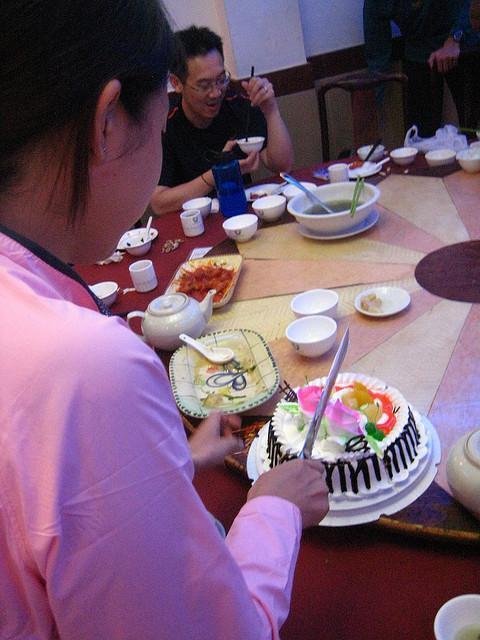How many people are visible?
Give a very brief answer. 3. How many wheels on the cement truck are not being used?
Give a very brief answer. 0. 